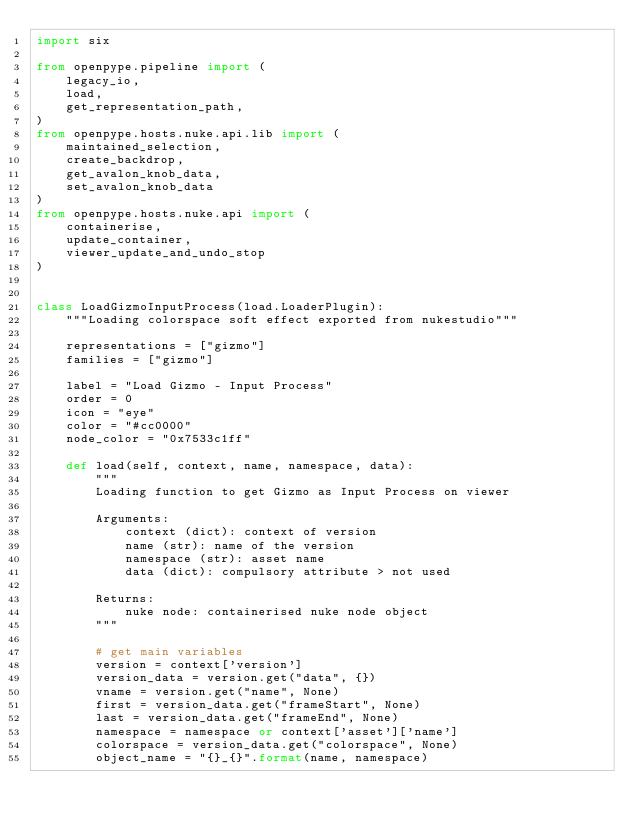Convert code to text. <code><loc_0><loc_0><loc_500><loc_500><_Python_>import six

from openpype.pipeline import (
    legacy_io,
    load,
    get_representation_path,
)
from openpype.hosts.nuke.api.lib import (
    maintained_selection,
    create_backdrop,
    get_avalon_knob_data,
    set_avalon_knob_data
)
from openpype.hosts.nuke.api import (
    containerise,
    update_container,
    viewer_update_and_undo_stop
)


class LoadGizmoInputProcess(load.LoaderPlugin):
    """Loading colorspace soft effect exported from nukestudio"""

    representations = ["gizmo"]
    families = ["gizmo"]

    label = "Load Gizmo - Input Process"
    order = 0
    icon = "eye"
    color = "#cc0000"
    node_color = "0x7533c1ff"

    def load(self, context, name, namespace, data):
        """
        Loading function to get Gizmo as Input Process on viewer

        Arguments:
            context (dict): context of version
            name (str): name of the version
            namespace (str): asset name
            data (dict): compulsory attribute > not used

        Returns:
            nuke node: containerised nuke node object
        """

        # get main variables
        version = context['version']
        version_data = version.get("data", {})
        vname = version.get("name", None)
        first = version_data.get("frameStart", None)
        last = version_data.get("frameEnd", None)
        namespace = namespace or context['asset']['name']
        colorspace = version_data.get("colorspace", None)
        object_name = "{}_{}".format(name, namespace)
</code> 